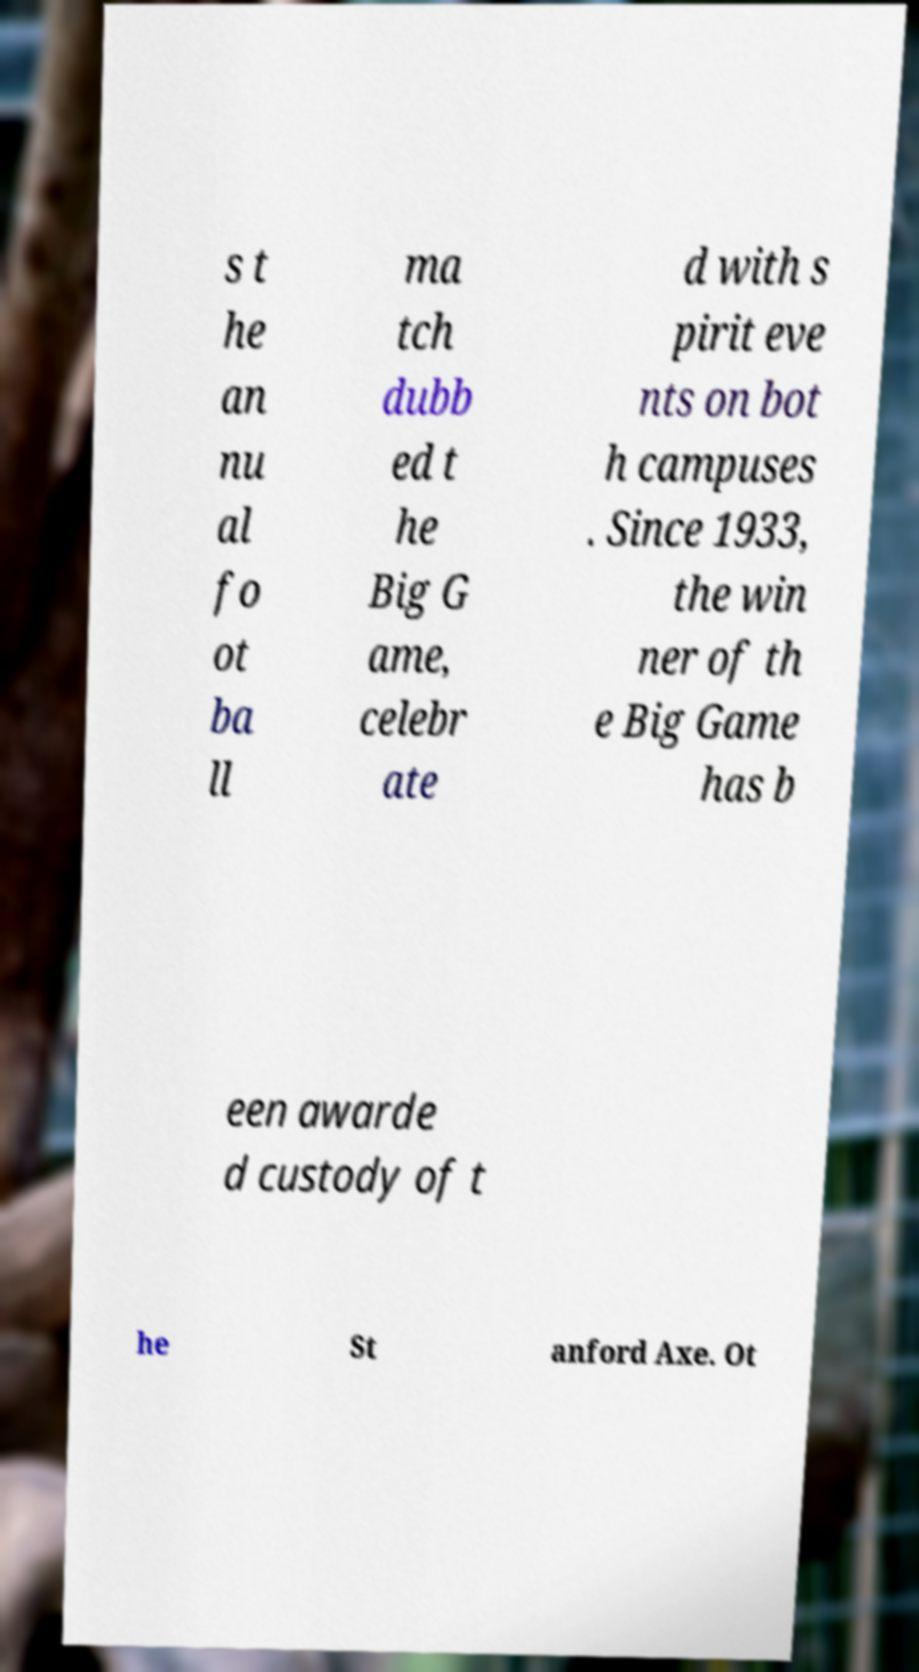Can you read and provide the text displayed in the image?This photo seems to have some interesting text. Can you extract and type it out for me? s t he an nu al fo ot ba ll ma tch dubb ed t he Big G ame, celebr ate d with s pirit eve nts on bot h campuses . Since 1933, the win ner of th e Big Game has b een awarde d custody of t he St anford Axe. Ot 